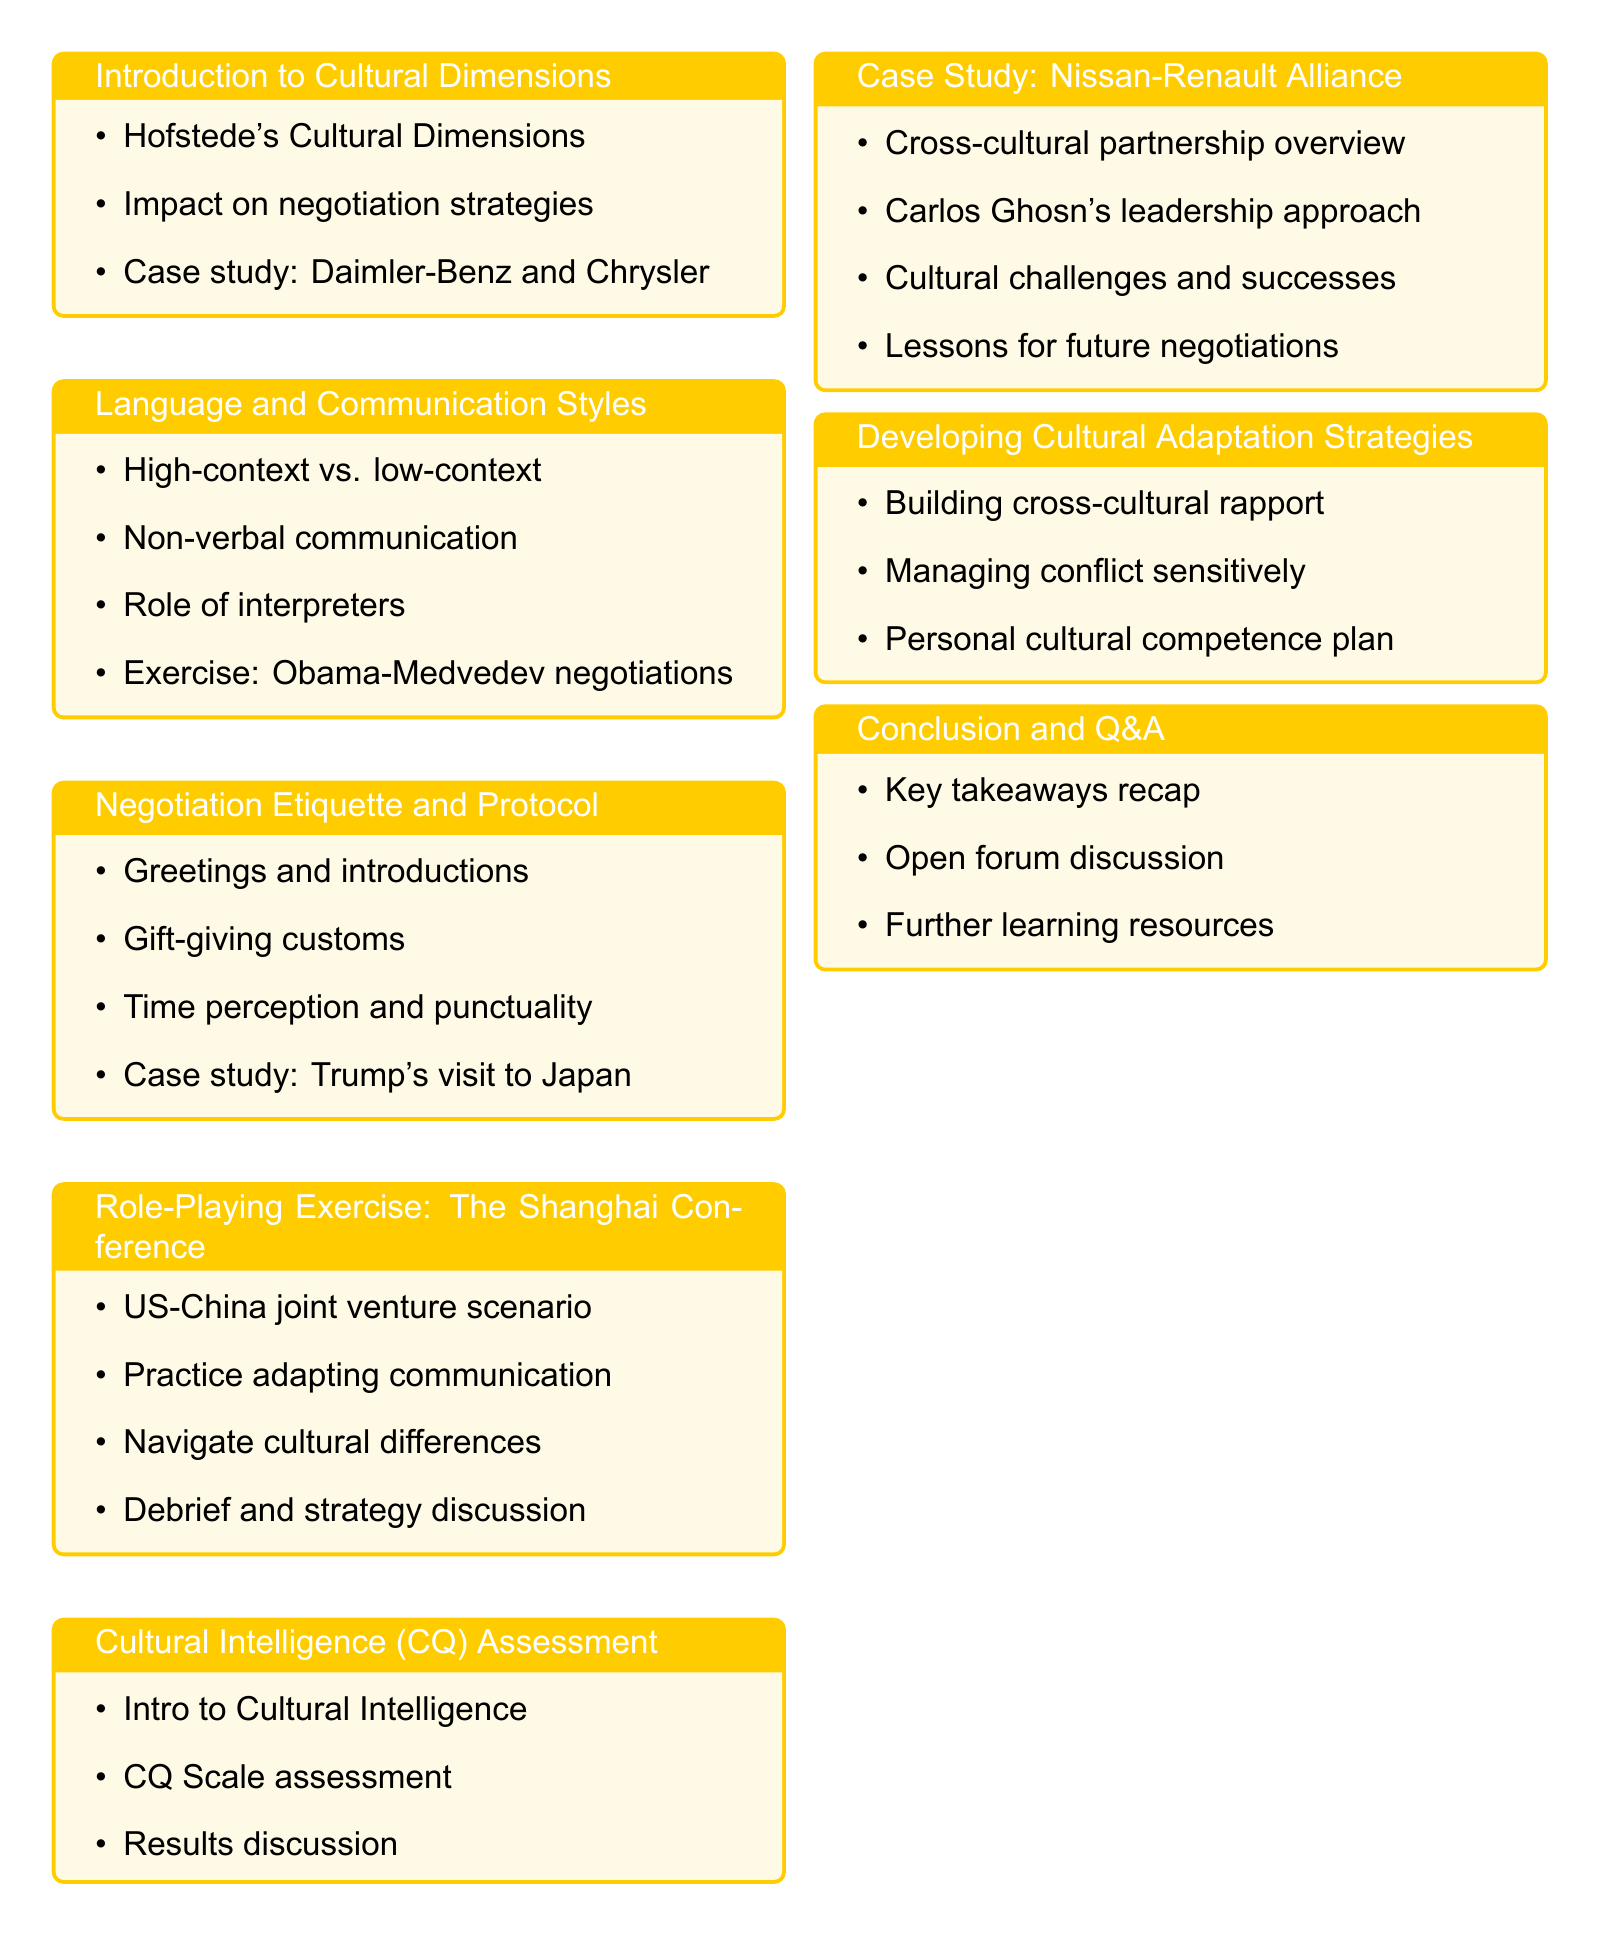What is the workshop title? The workshop title is explicitly mentioned at the beginning of the document.
Answer: Cultural Sensitivity in International Negotiations: A Comprehensive Workshop Who is the facilitator of the workshop? The facilitator's name is indicated in the document, specifically under the title.
Answer: Dr. Elena Petrova How long is the workshop? The duration of the workshop is clearly stated in the document.
Answer: Full-day workshop (8 hours) What is the first section of the workshop? The document lists the sections in order, with the first section being the introduction.
Answer: Introduction to Cultural Dimensions What case study is discussed in the "Cultural Dimensions" section? The document specifies the case studies covered within each section.
Answer: The failed merger between Daimler-Benz and Chrysler due to cultural misunderstandings What is the total duration allocated to the role-playing exercise? The duration for the role-playing exercise is provided in the document under its respective section.
Answer: 120 minutes What exercise analyzes communication styles in the workshop? The document describes an exercise related to communication styles in the relevant section.
Answer: Analyzing communication styles in the Obama-Medvedev negotiations What is one recommended reading from the workshop? The document lists recommended readings relevant to the workshop theme.
Answer: "The Culture Map" by Erin Meyer What is the last component of the workshop agenda? The components of the workshop agenda are listed sequentially, revealing the final segment.
Answer: Conclusion and Q&A 